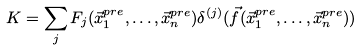Convert formula to latex. <formula><loc_0><loc_0><loc_500><loc_500>K = \sum _ { j } F _ { j } ( \vec { x } ^ { p r e } _ { 1 } , \dots , \vec { x } ^ { p r e } _ { n } ) \delta ^ { ( j ) } ( \vec { f } ( \vec { x } ^ { p r e } _ { 1 } , \dots , \vec { x } ^ { p r e } _ { n } ) )</formula> 